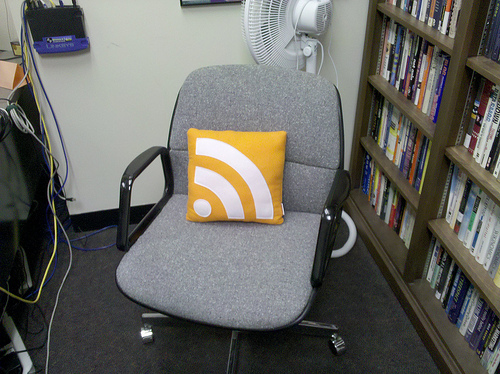<image>
Is there a book to the right of the fan? Yes. From this viewpoint, the book is positioned to the right side relative to the fan. Is the pillow on the chair? Yes. Looking at the image, I can see the pillow is positioned on top of the chair, with the chair providing support. 